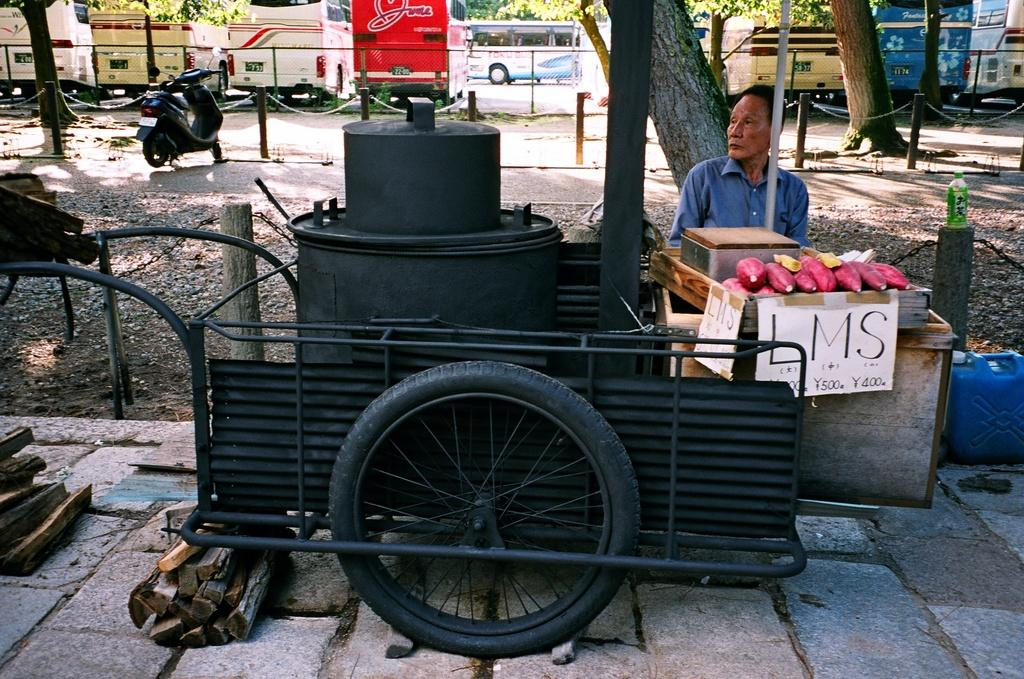What is the main subject of the image? There is a person in the image. What else can be seen in the image besides the person? There are fruits, a poster, a wheel, poles, a bottle, wooden sticks, a bike, a road, and vehicles in the background of the image. Can you describe the background of the image? In the background, there is a fence, trees, and vehicles. What might the person be doing with the wooden sticks? The wooden sticks could be used for various purposes, such as skewering fruits or cooking. What type of crack can be seen in the image? There is no crack present in the image. What kind of rice is being served with the fruits in the image? There is no rice present in the image. 